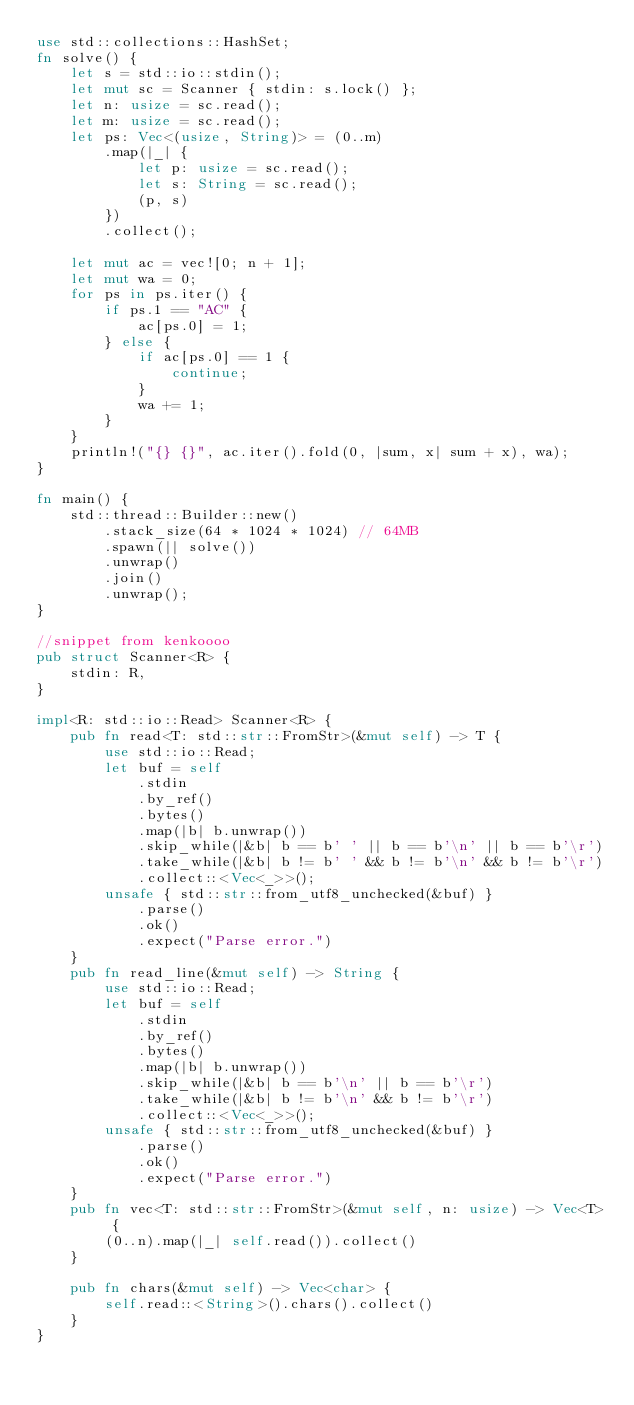<code> <loc_0><loc_0><loc_500><loc_500><_Rust_>use std::collections::HashSet;
fn solve() {
    let s = std::io::stdin();
    let mut sc = Scanner { stdin: s.lock() };
    let n: usize = sc.read();
    let m: usize = sc.read();
    let ps: Vec<(usize, String)> = (0..m)
        .map(|_| {
            let p: usize = sc.read();
            let s: String = sc.read();
            (p, s)
        })
        .collect();

    let mut ac = vec![0; n + 1];
    let mut wa = 0;
    for ps in ps.iter() {
        if ps.1 == "AC" {
            ac[ps.0] = 1;
        } else {
            if ac[ps.0] == 1 {
                continue;
            }
            wa += 1;
        }
    }
    println!("{} {}", ac.iter().fold(0, |sum, x| sum + x), wa);
}

fn main() {
    std::thread::Builder::new()
        .stack_size(64 * 1024 * 1024) // 64MB
        .spawn(|| solve())
        .unwrap()
        .join()
        .unwrap();
}

//snippet from kenkoooo
pub struct Scanner<R> {
    stdin: R,
}

impl<R: std::io::Read> Scanner<R> {
    pub fn read<T: std::str::FromStr>(&mut self) -> T {
        use std::io::Read;
        let buf = self
            .stdin
            .by_ref()
            .bytes()
            .map(|b| b.unwrap())
            .skip_while(|&b| b == b' ' || b == b'\n' || b == b'\r')
            .take_while(|&b| b != b' ' && b != b'\n' && b != b'\r')
            .collect::<Vec<_>>();
        unsafe { std::str::from_utf8_unchecked(&buf) }
            .parse()
            .ok()
            .expect("Parse error.")
    }
    pub fn read_line(&mut self) -> String {
        use std::io::Read;
        let buf = self
            .stdin
            .by_ref()
            .bytes()
            .map(|b| b.unwrap())
            .skip_while(|&b| b == b'\n' || b == b'\r')
            .take_while(|&b| b != b'\n' && b != b'\r')
            .collect::<Vec<_>>();
        unsafe { std::str::from_utf8_unchecked(&buf) }
            .parse()
            .ok()
            .expect("Parse error.")
    }
    pub fn vec<T: std::str::FromStr>(&mut self, n: usize) -> Vec<T> {
        (0..n).map(|_| self.read()).collect()
    }

    pub fn chars(&mut self) -> Vec<char> {
        self.read::<String>().chars().collect()
    }
}
</code> 